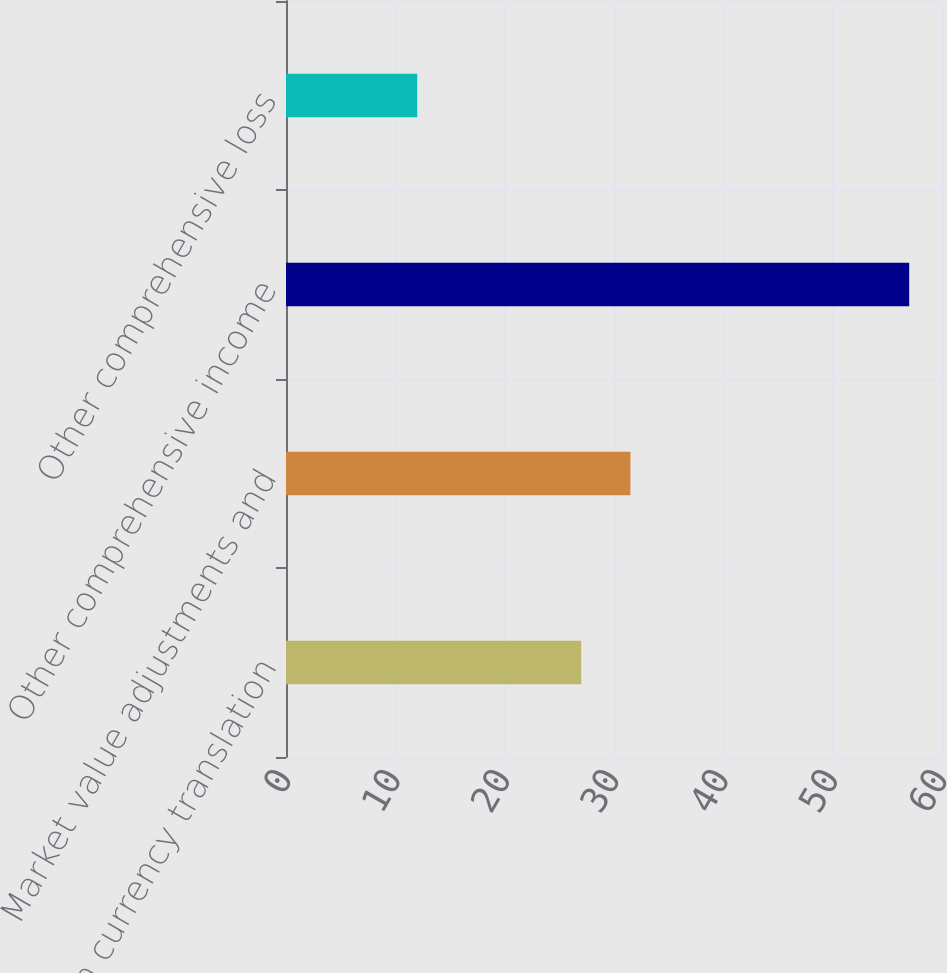<chart> <loc_0><loc_0><loc_500><loc_500><bar_chart><fcel>Foreign currency translation<fcel>Market value adjustments and<fcel>Other comprehensive income<fcel>Other comprehensive loss<nl><fcel>27<fcel>31.5<fcel>57<fcel>12<nl></chart> 